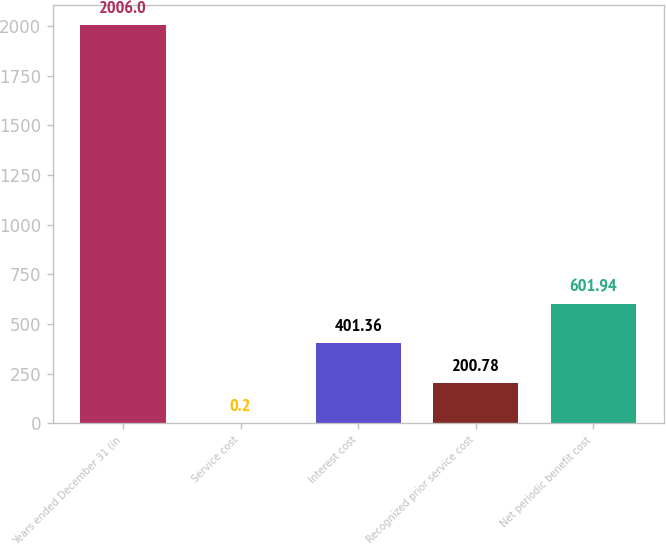Convert chart. <chart><loc_0><loc_0><loc_500><loc_500><bar_chart><fcel>Years ended December 31 (in<fcel>Service cost<fcel>Interest cost<fcel>Recognized prior service cost<fcel>Net periodic benefit cost<nl><fcel>2006<fcel>0.2<fcel>401.36<fcel>200.78<fcel>601.94<nl></chart> 